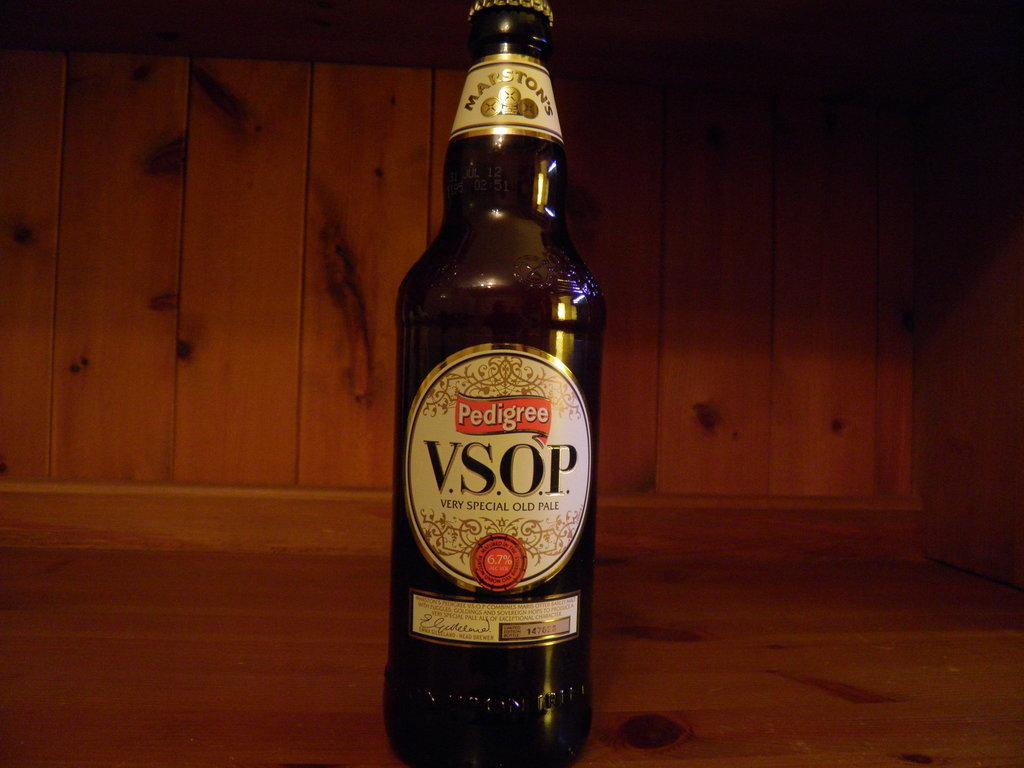<image>
Relay a brief, clear account of the picture shown. A bottle of Very Special Old Pale rests in a wooden shelf. 